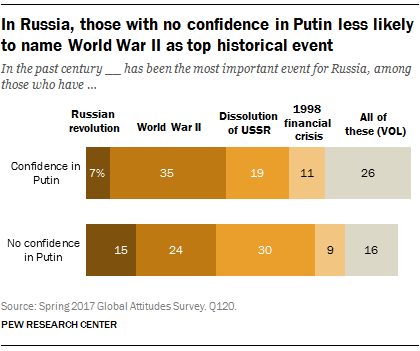Outline some significant characteristics in this image. The graph displays 5 colors. It is estimated that approximately 22% of those surveyed had no confidence in the Russian Revolution and another 22% had confidence in it. 